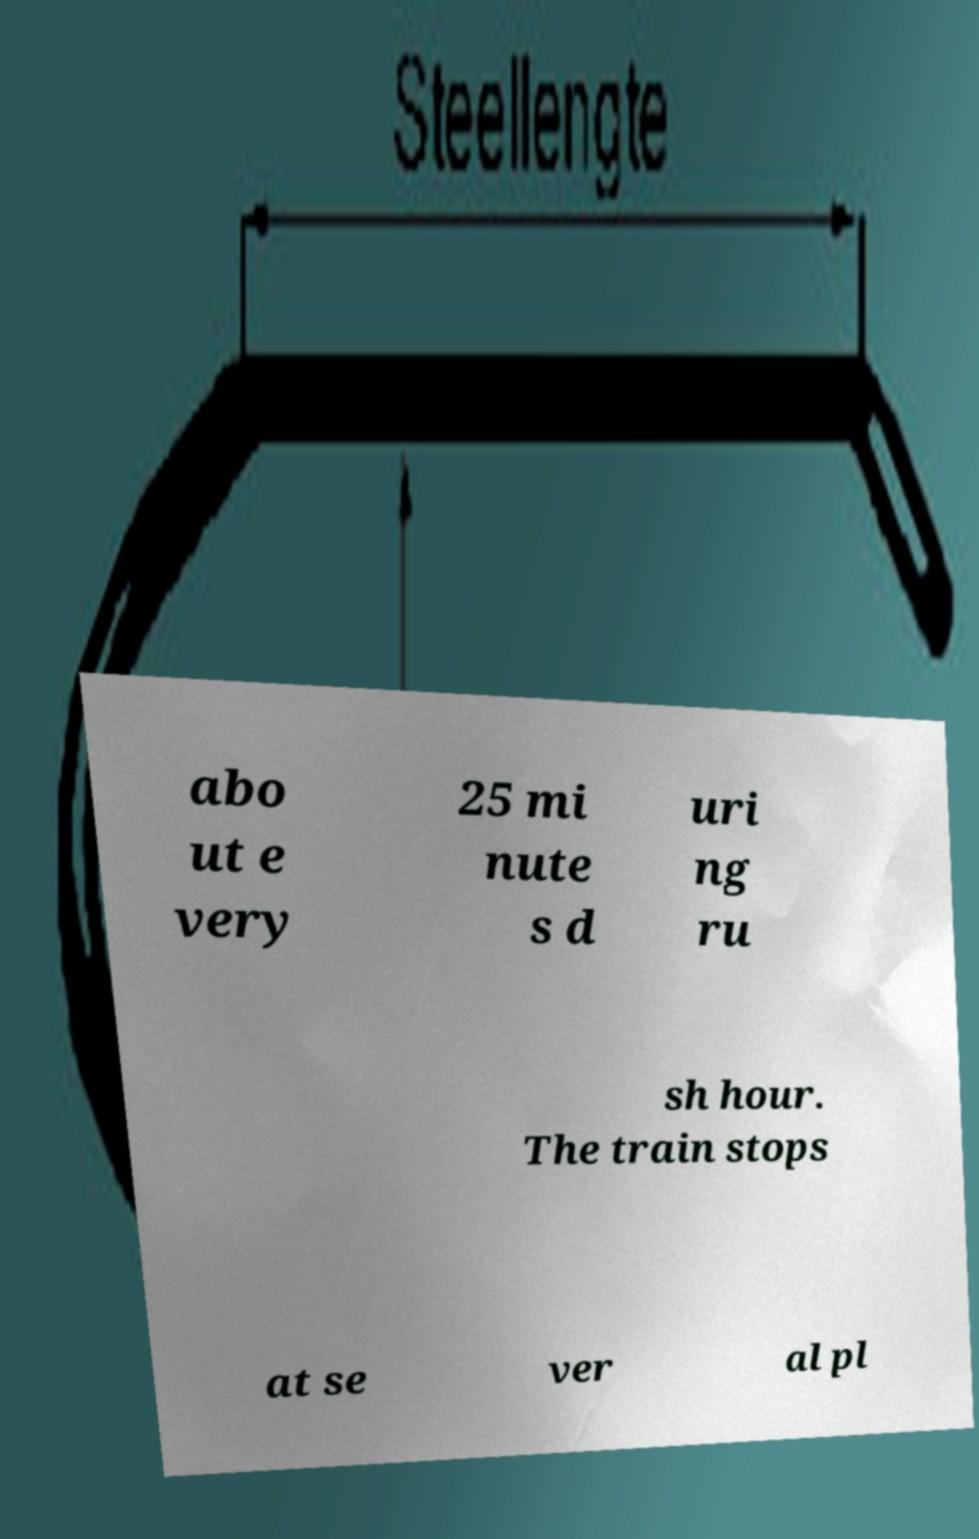What messages or text are displayed in this image? I need them in a readable, typed format. abo ut e very 25 mi nute s d uri ng ru sh hour. The train stops at se ver al pl 